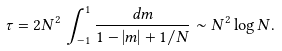Convert formula to latex. <formula><loc_0><loc_0><loc_500><loc_500>\tau = 2 N ^ { 2 } \, \int _ { - 1 } ^ { 1 } \frac { d m } { 1 - | m | + 1 / N } \sim N ^ { 2 } \log N .</formula> 